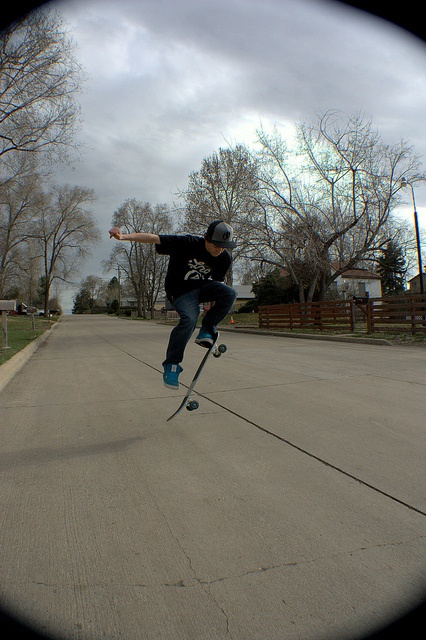Describe the objects in this image and their specific colors. I can see people in black, gray, maroon, and darkblue tones and skateboard in black and gray tones in this image. 